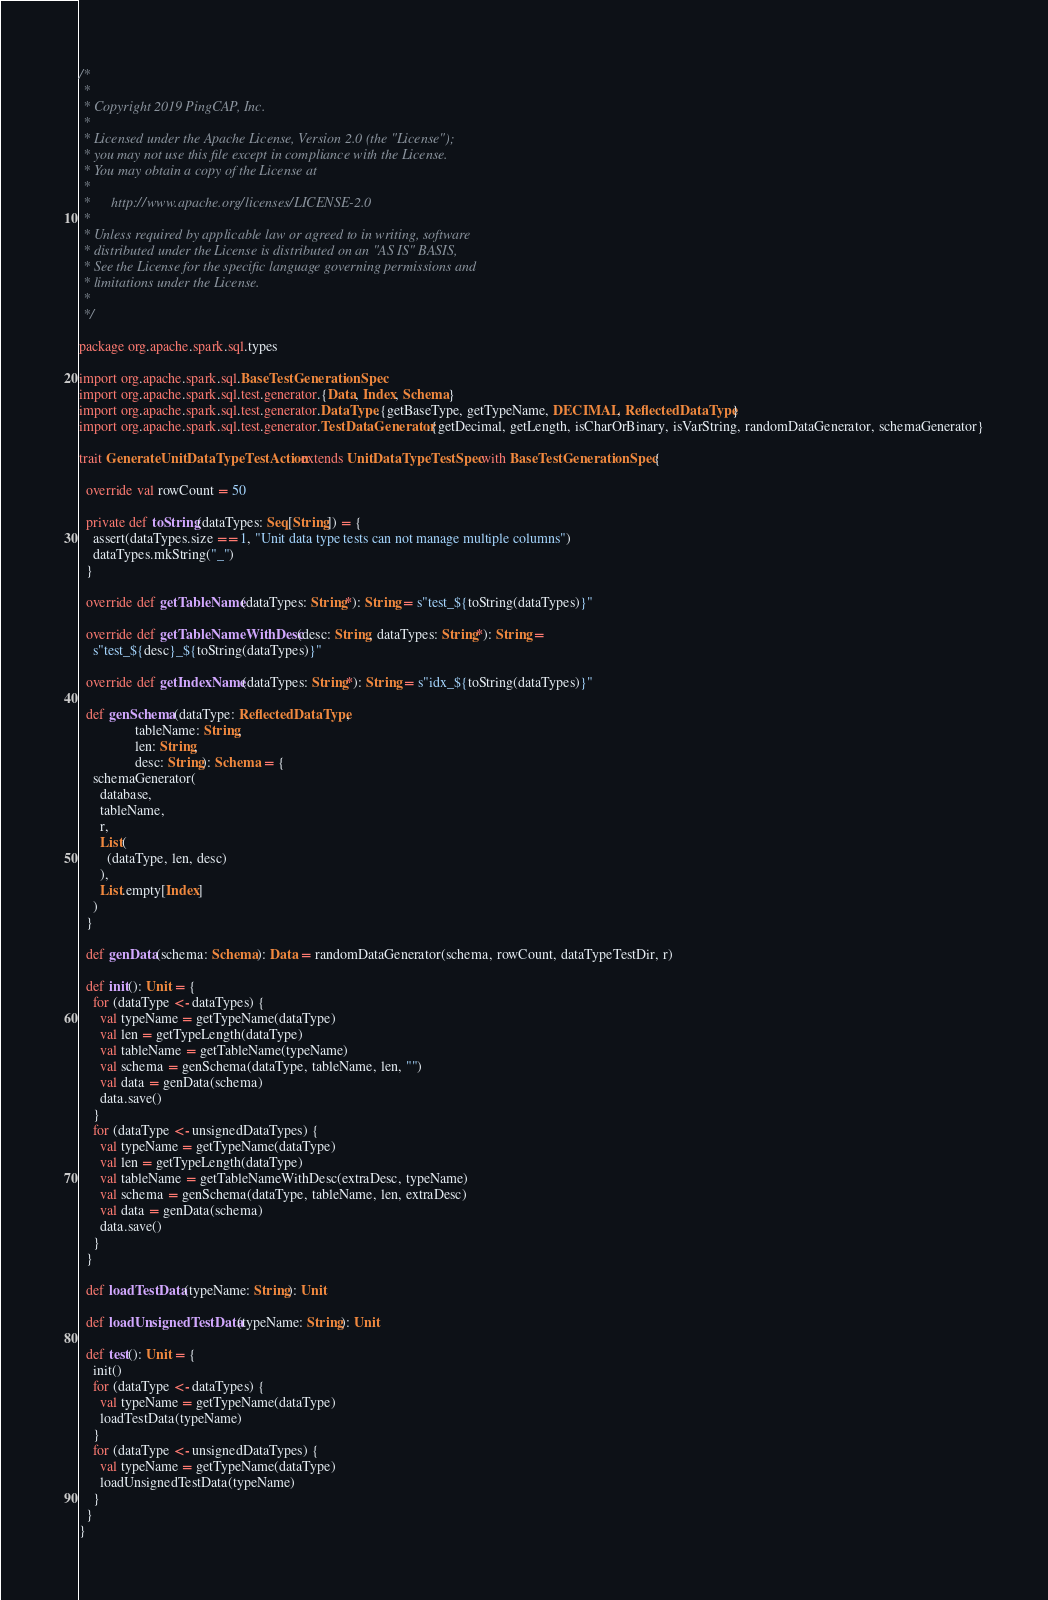<code> <loc_0><loc_0><loc_500><loc_500><_Scala_>/*
 *
 * Copyright 2019 PingCAP, Inc.
 *
 * Licensed under the Apache License, Version 2.0 (the "License");
 * you may not use this file except in compliance with the License.
 * You may obtain a copy of the License at
 *
 *      http://www.apache.org/licenses/LICENSE-2.0
 *
 * Unless required by applicable law or agreed to in writing, software
 * distributed under the License is distributed on an "AS IS" BASIS,
 * See the License for the specific language governing permissions and
 * limitations under the License.
 *
 */

package org.apache.spark.sql.types

import org.apache.spark.sql.BaseTestGenerationSpec
import org.apache.spark.sql.test.generator.{Data, Index, Schema}
import org.apache.spark.sql.test.generator.DataType.{getBaseType, getTypeName, DECIMAL, ReflectedDataType}
import org.apache.spark.sql.test.generator.TestDataGenerator.{getDecimal, getLength, isCharOrBinary, isVarString, randomDataGenerator, schemaGenerator}

trait GenerateUnitDataTypeTestAction extends UnitDataTypeTestSpec with BaseTestGenerationSpec {

  override val rowCount = 50

  private def toString(dataTypes: Seq[String]) = {
    assert(dataTypes.size == 1, "Unit data type tests can not manage multiple columns")
    dataTypes.mkString("_")
  }

  override def getTableName(dataTypes: String*): String = s"test_${toString(dataTypes)}"

  override def getTableNameWithDesc(desc: String, dataTypes: String*): String =
    s"test_${desc}_${toString(dataTypes)}"

  override def getIndexName(dataTypes: String*): String = s"idx_${toString(dataTypes)}"

  def genSchema(dataType: ReflectedDataType,
                tableName: String,
                len: String,
                desc: String): Schema = {
    schemaGenerator(
      database,
      tableName,
      r,
      List(
        (dataType, len, desc)
      ),
      List.empty[Index]
    )
  }

  def genData(schema: Schema): Data = randomDataGenerator(schema, rowCount, dataTypeTestDir, r)

  def init(): Unit = {
    for (dataType <- dataTypes) {
      val typeName = getTypeName(dataType)
      val len = getTypeLength(dataType)
      val tableName = getTableName(typeName)
      val schema = genSchema(dataType, tableName, len, "")
      val data = genData(schema)
      data.save()
    }
    for (dataType <- unsignedDataTypes) {
      val typeName = getTypeName(dataType)
      val len = getTypeLength(dataType)
      val tableName = getTableNameWithDesc(extraDesc, typeName)
      val schema = genSchema(dataType, tableName, len, extraDesc)
      val data = genData(schema)
      data.save()
    }
  }

  def loadTestData(typeName: String): Unit

  def loadUnsignedTestData(typeName: String): Unit

  def test(): Unit = {
    init()
    for (dataType <- dataTypes) {
      val typeName = getTypeName(dataType)
      loadTestData(typeName)
    }
    for (dataType <- unsignedDataTypes) {
      val typeName = getTypeName(dataType)
      loadUnsignedTestData(typeName)
    }
  }
}
</code> 